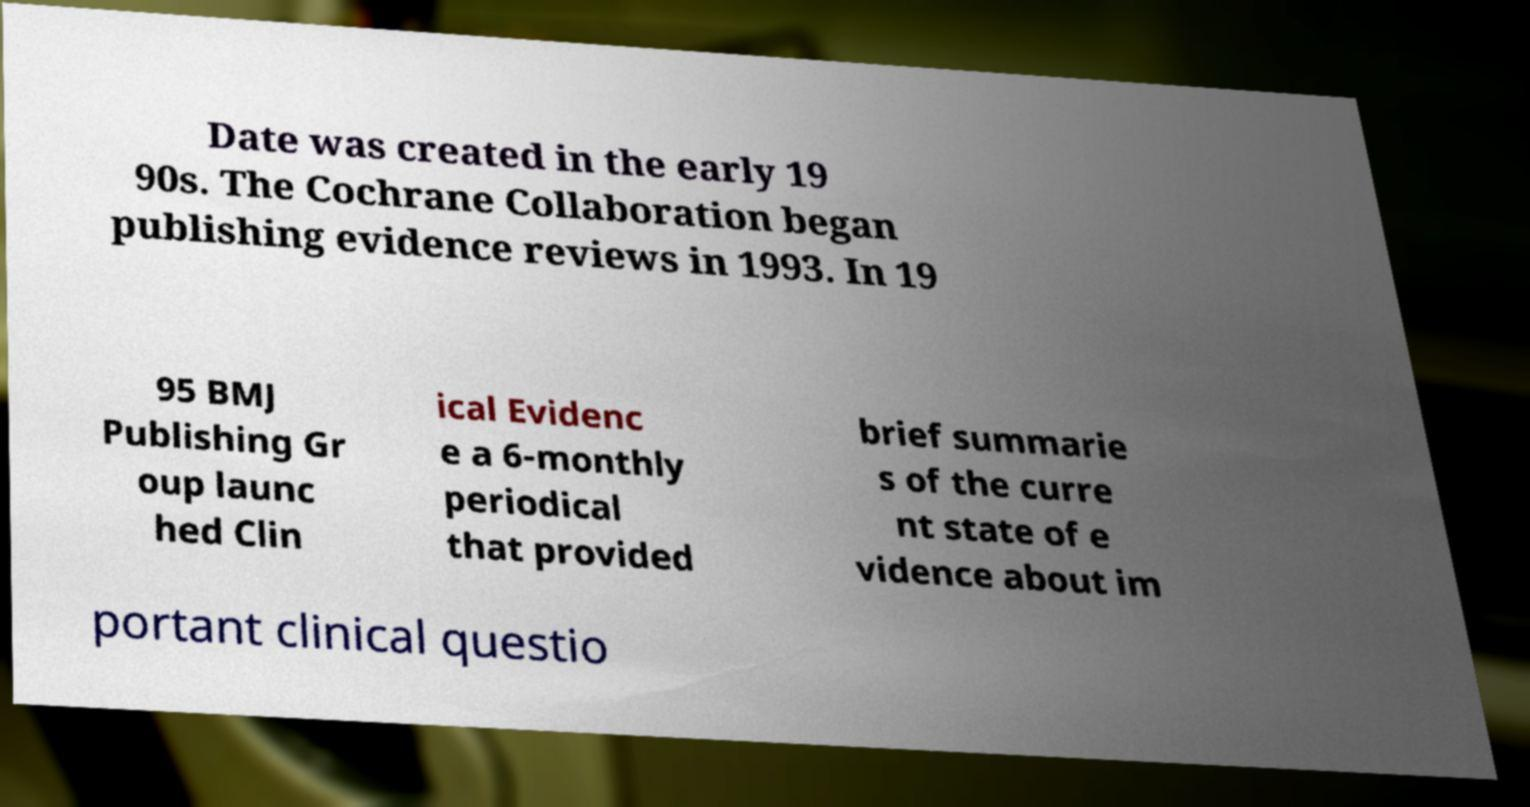Could you assist in decoding the text presented in this image and type it out clearly? Date was created in the early 19 90s. The Cochrane Collaboration began publishing evidence reviews in 1993. In 19 95 BMJ Publishing Gr oup launc hed Clin ical Evidenc e a 6-monthly periodical that provided brief summarie s of the curre nt state of e vidence about im portant clinical questio 